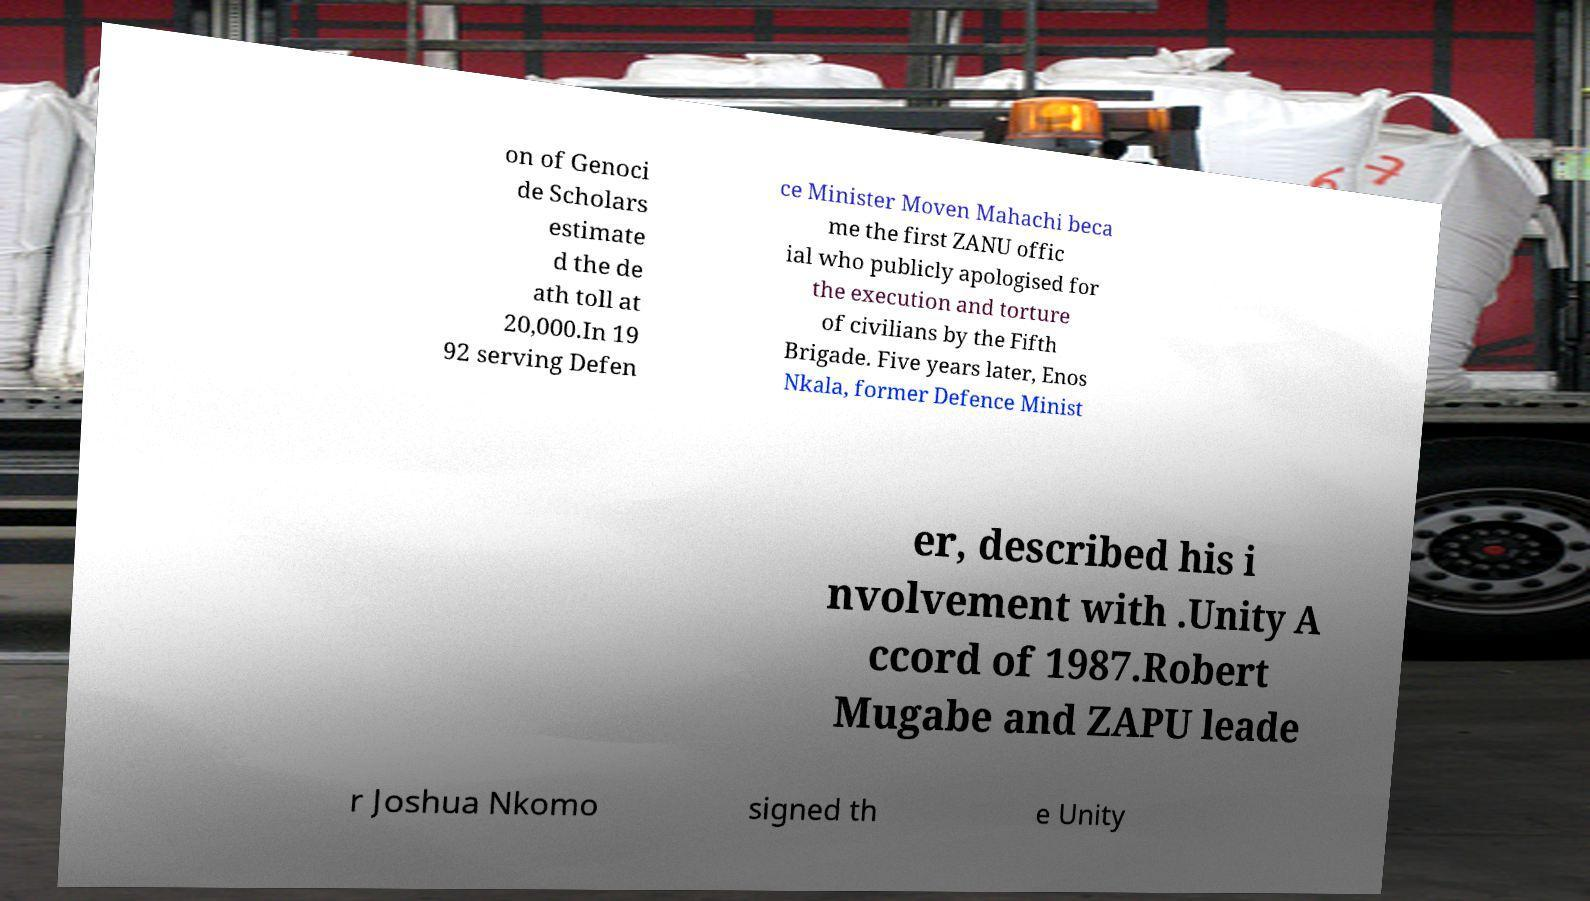What messages or text are displayed in this image? I need them in a readable, typed format. on of Genoci de Scholars estimate d the de ath toll at 20,000.In 19 92 serving Defen ce Minister Moven Mahachi beca me the first ZANU offic ial who publicly apologised for the execution and torture of civilians by the Fifth Brigade. Five years later, Enos Nkala, former Defence Minist er, described his i nvolvement with .Unity A ccord of 1987.Robert Mugabe and ZAPU leade r Joshua Nkomo signed th e Unity 